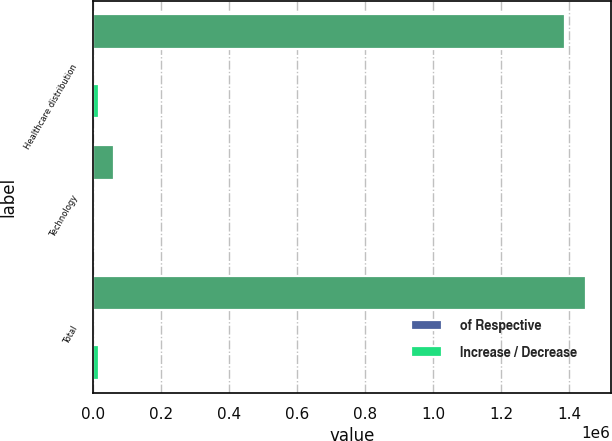Convert chart. <chart><loc_0><loc_0><loc_500><loc_500><stacked_bar_chart><ecel><fcel>Healthcare distribution<fcel>Technology<fcel>Total<nl><fcel>nan<fcel>1.38758e+06<fcel>62134<fcel>1.44972e+06<nl><fcel>of Respective<fcel>21.8<fcel>35.9<fcel>22.2<nl><fcel>Increase / Decrease<fcel>19473<fcel>1527<fcel>17946<nl></chart> 